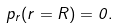<formula> <loc_0><loc_0><loc_500><loc_500>p _ { r } ( r = R ) = 0 .</formula> 